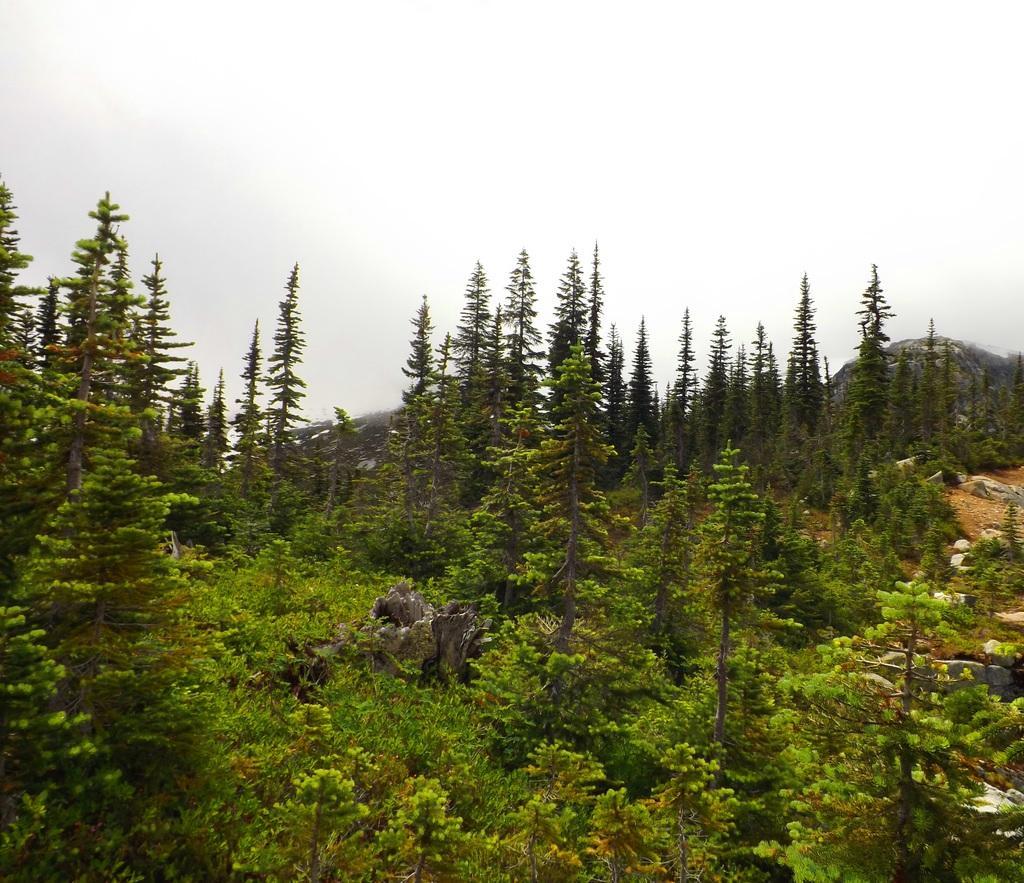Could you give a brief overview of what you see in this image? These are the trees and plants. This looks like a rock. I can see a tree trunk. I think this is the forest. 